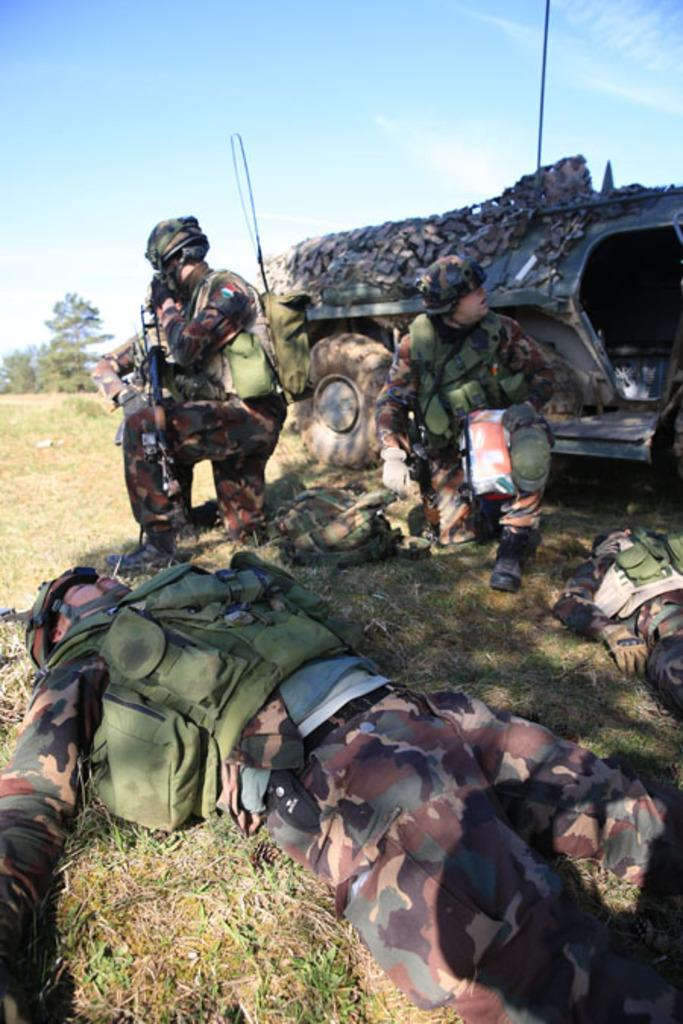What is the main subject in the foreground of the picture? There are men in the foreground of the picture. Where are the men located in the image? The men are on the grass. What can be seen in the background of the image? There is a military tank and a tree in the background of the image. What type of vegetation is visible in the background of the image? Grass is present in the background of the image. What is visible in the sky in the image? The sky is visible in the background of the image. What type of veil is draped over the military tank in the image? There is no veil present in the image; the military tank is visible without any covering. 